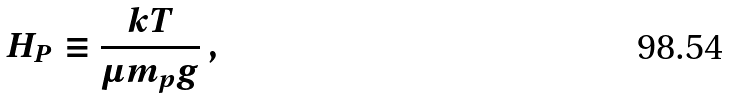<formula> <loc_0><loc_0><loc_500><loc_500>H _ { P } \equiv \frac { k T } { \mu m _ { p } g } \, ,</formula> 